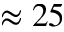<formula> <loc_0><loc_0><loc_500><loc_500>\approx 2 5</formula> 